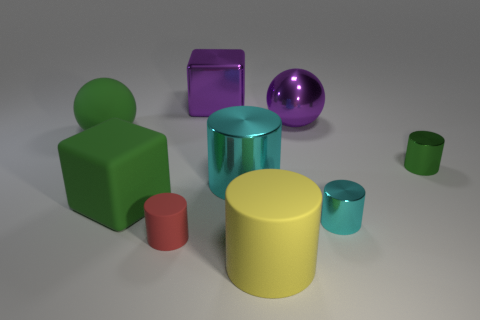What size is the green matte object in front of the green object that is right of the large purple shiny block?
Offer a terse response. Large. What is the object that is both left of the red matte thing and behind the green metallic cylinder made of?
Your answer should be compact. Rubber. How many other objects are the same size as the purple metal ball?
Your answer should be compact. 5. The big rubber cylinder has what color?
Provide a succinct answer. Yellow. There is a tiny cylinder on the left side of the purple ball; is its color the same as the small cylinder behind the big cyan cylinder?
Keep it short and to the point. No. How big is the red cylinder?
Provide a succinct answer. Small. What size is the purple block that is to the right of the red matte object?
Your response must be concise. Large. The matte object that is both in front of the green metallic object and behind the tiny red cylinder has what shape?
Ensure brevity in your answer.  Cube. What number of other things are the same shape as the small red matte object?
Give a very brief answer. 4. The shiny cylinder that is the same size as the green matte block is what color?
Make the answer very short. Cyan. 